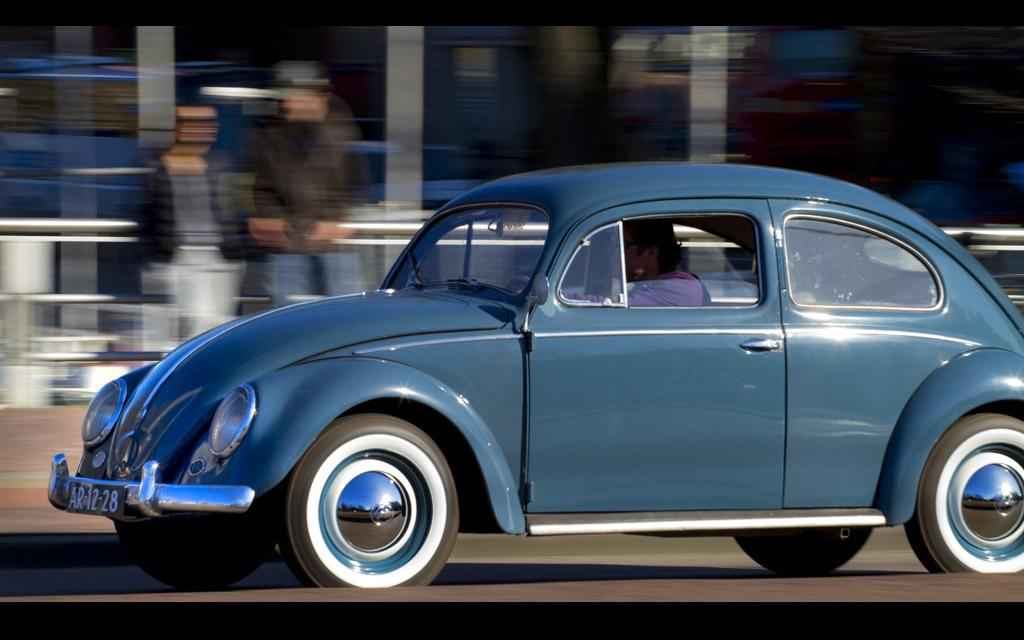Where is the image taken? The image is taken outside a road. What can be seen on the road in the image? A blue car is passing by on the road. Who is inside the blue car? There is a person inside the blue car. Can you describe the people in the background? There are two persons in the background. How would you describe the appearance of the background? The background appears hazy. Can you see any lumber being transported in the image? There is no lumber visible in the image. Is the ocean visible in the background of the image? The image does not show any ocean; it is taken outside a road with a hazy background. 